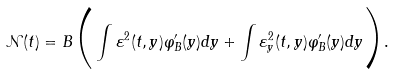Convert formula to latex. <formula><loc_0><loc_0><loc_500><loc_500>\mathcal { N } ( t ) = B \Big { ( } \int \varepsilon ^ { 2 } ( t , y ) \varphi _ { B } ^ { \prime } ( y ) d y + \int \varepsilon _ { y } ^ { 2 } ( t , y ) \varphi _ { B } ^ { \prime } ( y ) d y \Big { ) } .</formula> 